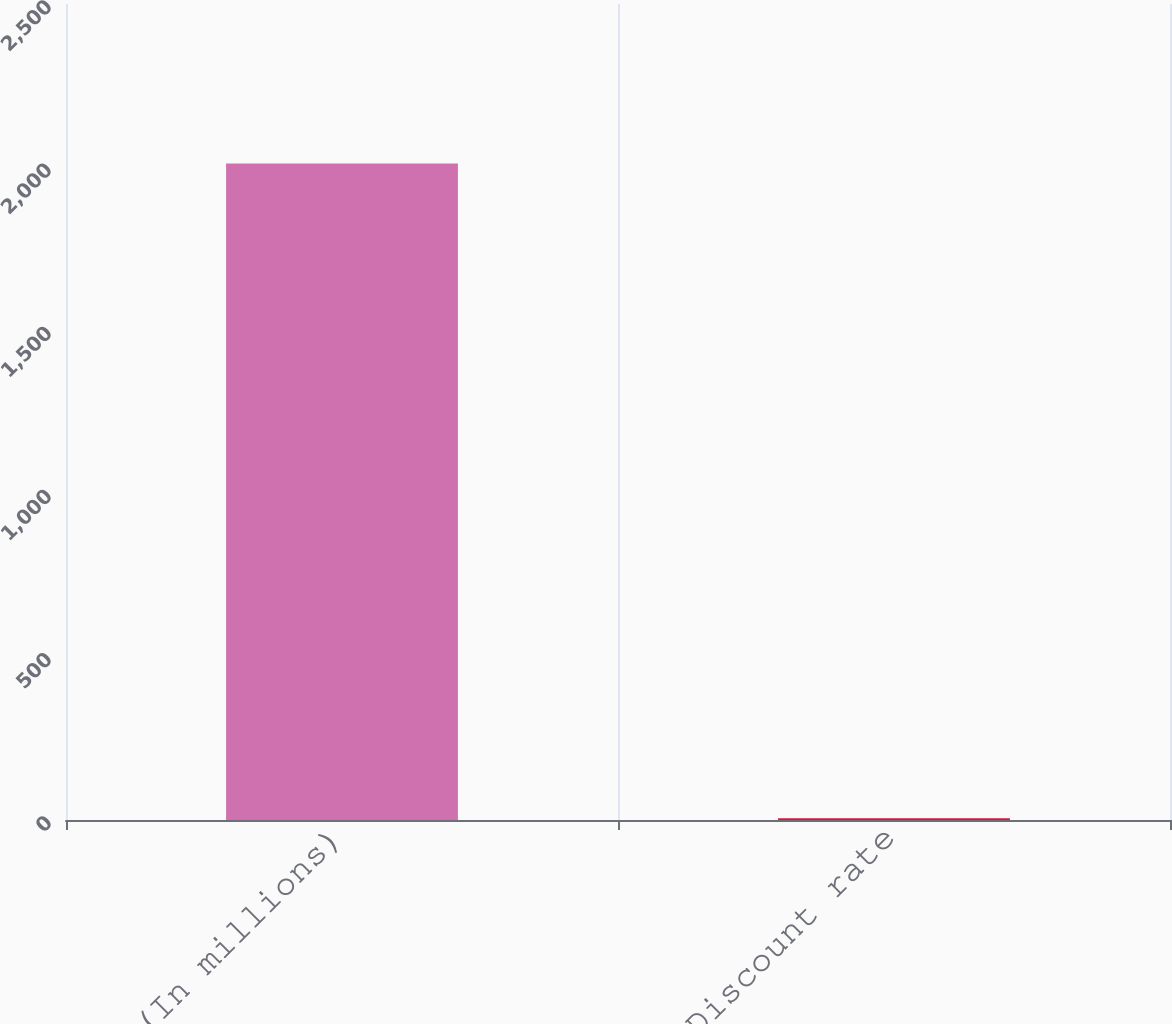Convert chart to OTSL. <chart><loc_0><loc_0><loc_500><loc_500><bar_chart><fcel>(In millions)<fcel>Discount rate<nl><fcel>2011<fcel>5.25<nl></chart> 